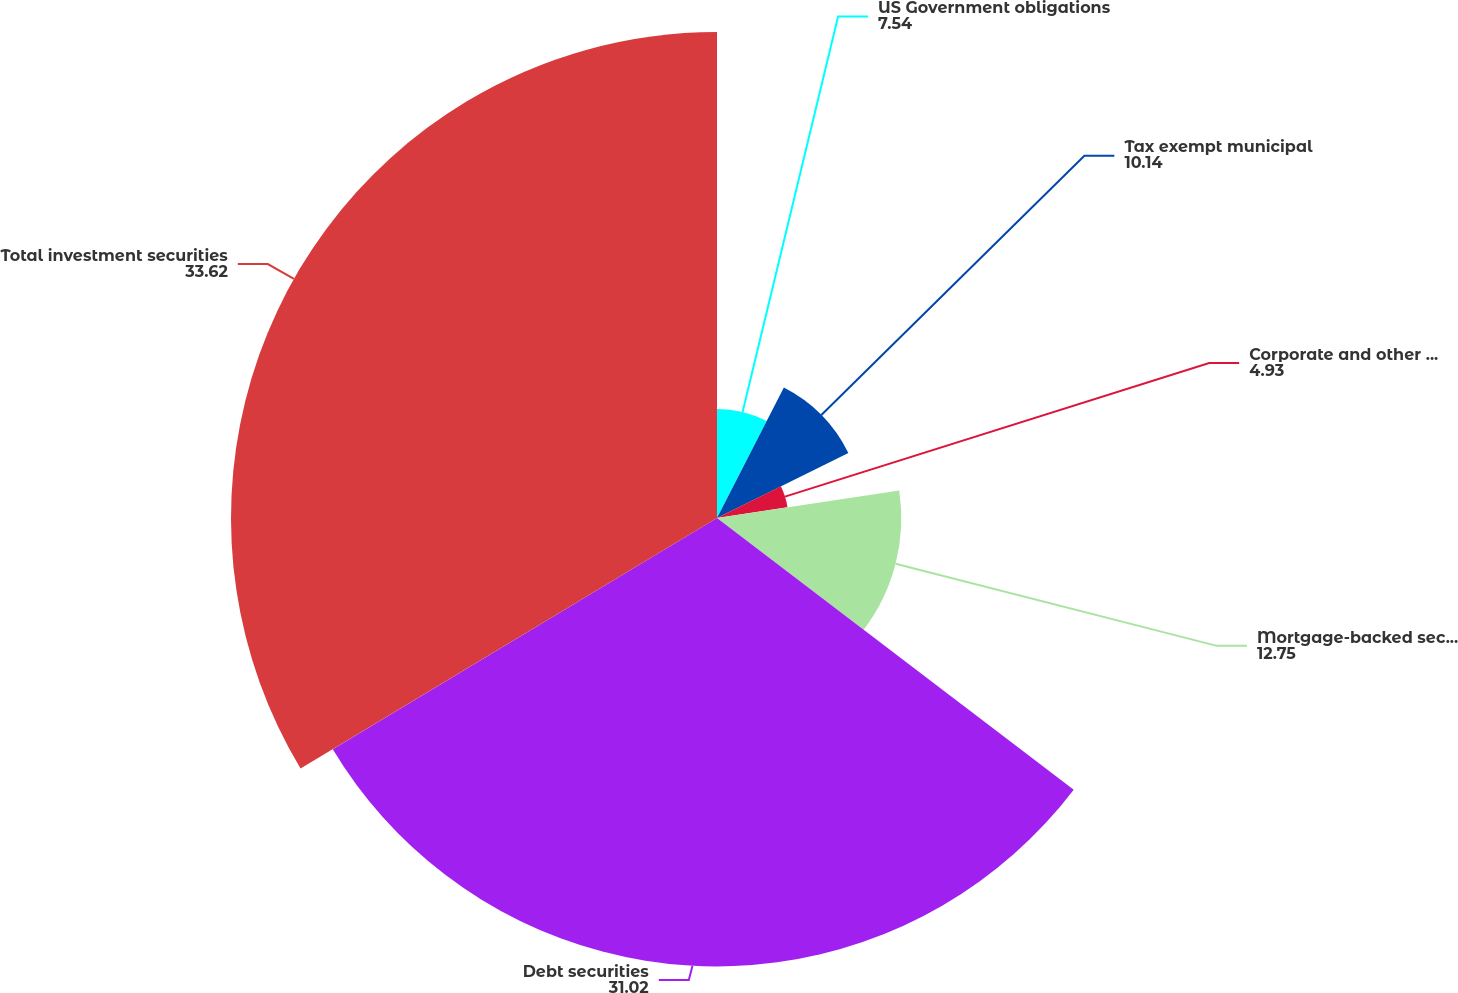Convert chart to OTSL. <chart><loc_0><loc_0><loc_500><loc_500><pie_chart><fcel>US Government obligations<fcel>Tax exempt municipal<fcel>Corporate and other securities<fcel>Mortgage-backed securities<fcel>Debt securities<fcel>Total investment securities<nl><fcel>7.54%<fcel>10.14%<fcel>4.93%<fcel>12.75%<fcel>31.02%<fcel>33.62%<nl></chart> 